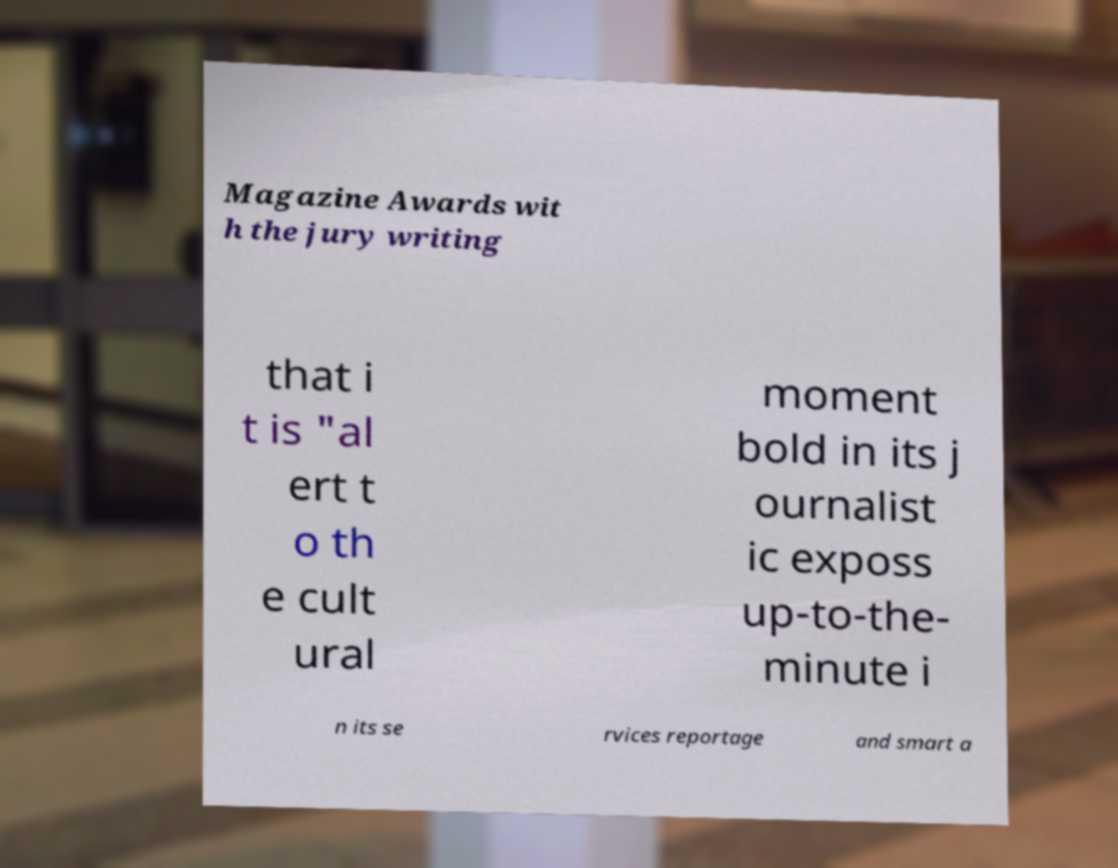There's text embedded in this image that I need extracted. Can you transcribe it verbatim? Magazine Awards wit h the jury writing that i t is "al ert t o th e cult ural moment bold in its j ournalist ic exposs up-to-the- minute i n its se rvices reportage and smart a 